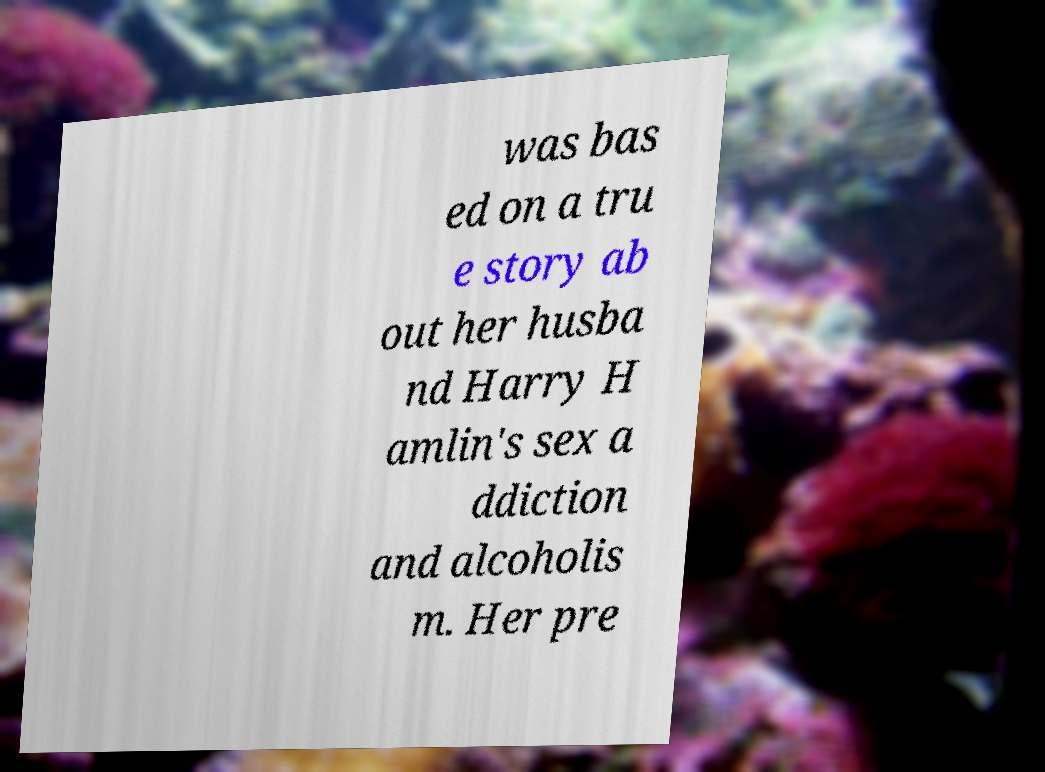Please read and relay the text visible in this image. What does it say? was bas ed on a tru e story ab out her husba nd Harry H amlin's sex a ddiction and alcoholis m. Her pre 